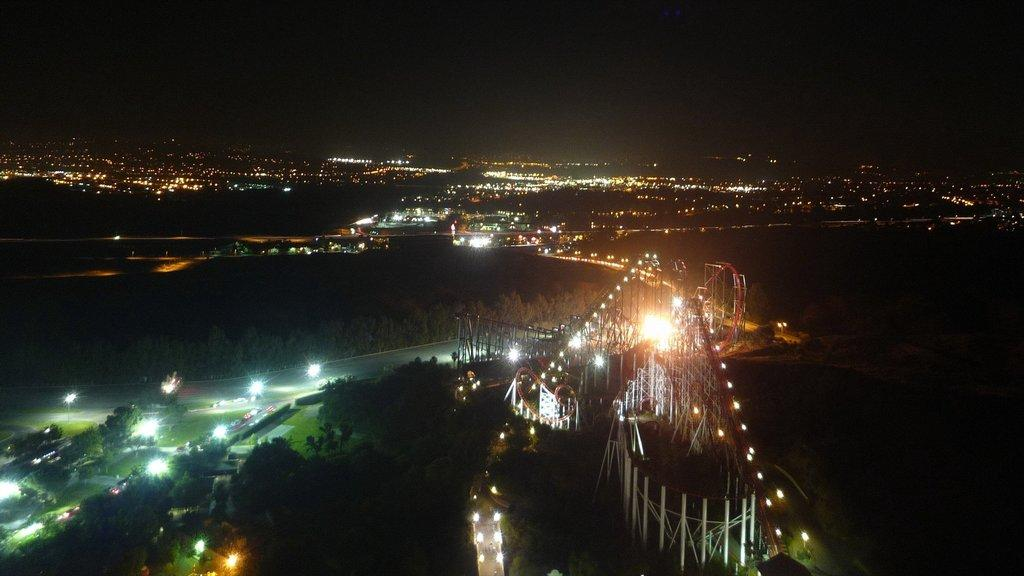What type of illumination is present in the image? There are lights in the image. What type of vegetation can be seen in the image? There is green grass visible in the image. What type of pathway is present in the image? There is a road in the image. What type of natural feature is present in the image? There are trees in the image. What type of crack is visible in the image? There is no crack present in the image. What type of chalk is used to draw on the grass in the image? There is no chalk or drawing on the grass in the image. 